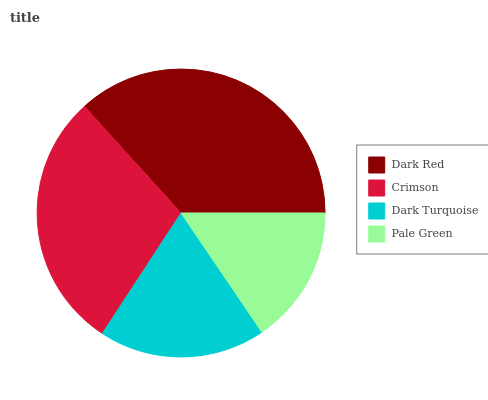Is Pale Green the minimum?
Answer yes or no. Yes. Is Dark Red the maximum?
Answer yes or no. Yes. Is Crimson the minimum?
Answer yes or no. No. Is Crimson the maximum?
Answer yes or no. No. Is Dark Red greater than Crimson?
Answer yes or no. Yes. Is Crimson less than Dark Red?
Answer yes or no. Yes. Is Crimson greater than Dark Red?
Answer yes or no. No. Is Dark Red less than Crimson?
Answer yes or no. No. Is Crimson the high median?
Answer yes or no. Yes. Is Dark Turquoise the low median?
Answer yes or no. Yes. Is Dark Turquoise the high median?
Answer yes or no. No. Is Crimson the low median?
Answer yes or no. No. 